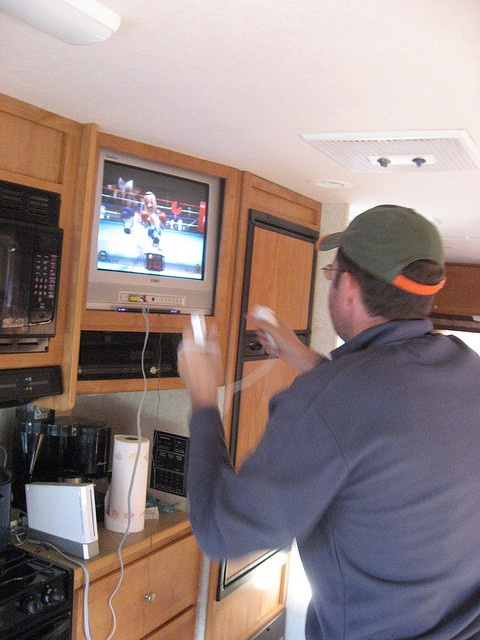Describe the objects in this image and their specific colors. I can see people in darkgray, gray, brown, and black tones, tv in darkgray, white, and gray tones, microwave in darkgray, black, gray, and brown tones, oven in darkgray, black, gray, and darkblue tones, and remote in darkgray and lightgray tones in this image. 